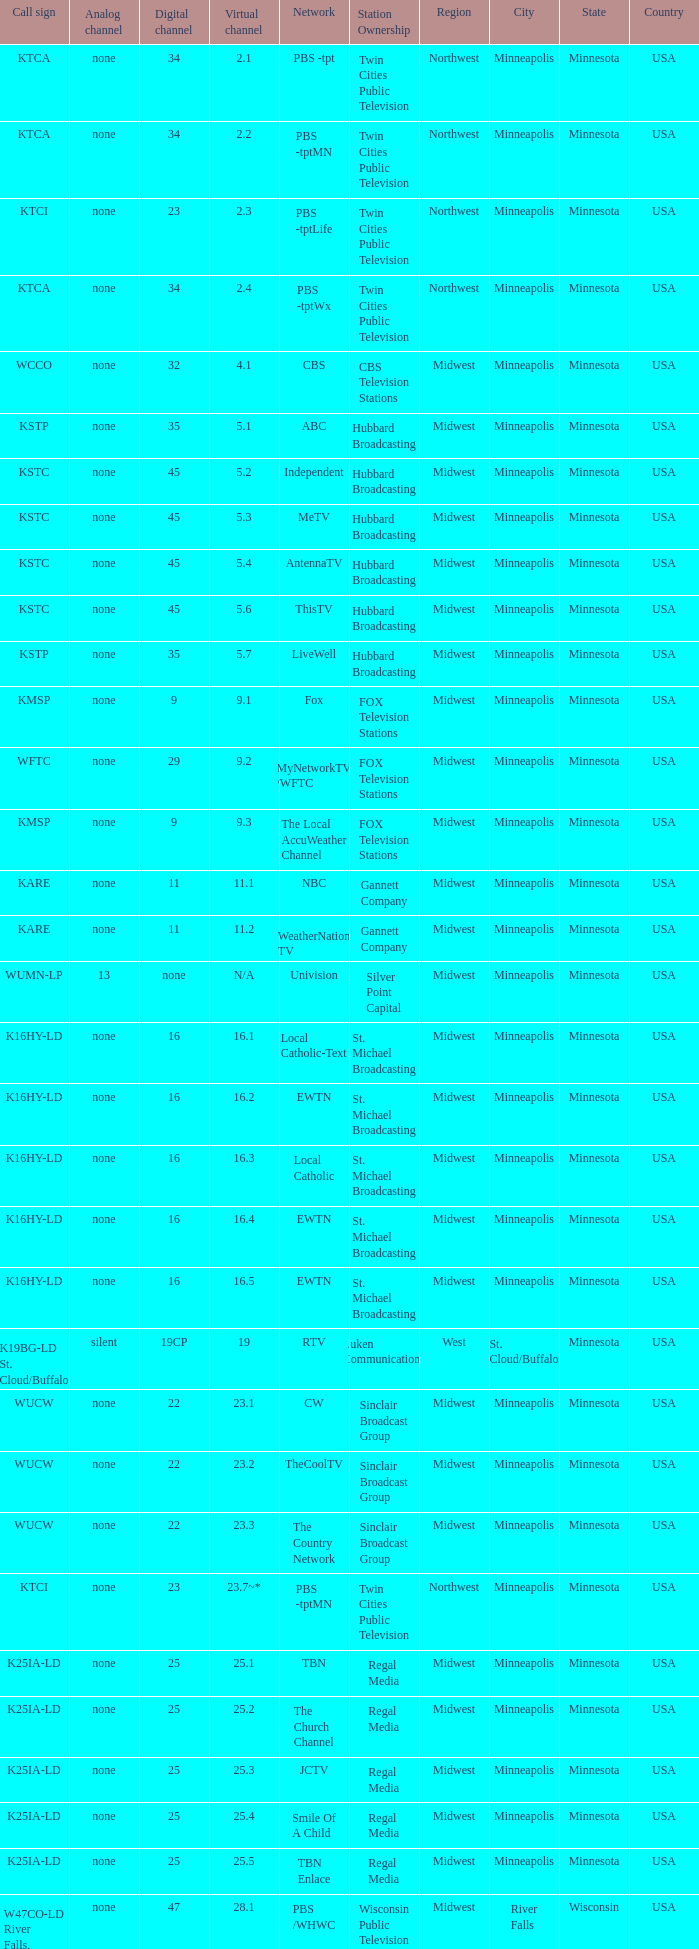For the station with ownership of eicb tv and a call sign of ktcj-ld, which virtual network is it a part of? 50.1. 